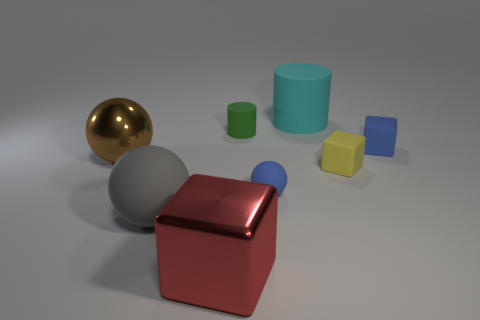Do the blue thing behind the big brown object and the blue matte sphere that is behind the big gray ball have the same size?
Provide a succinct answer. Yes. What number of gray objects are either large matte things or matte balls?
Your answer should be very brief. 1. There is a block that is the same color as the small rubber sphere; what is its size?
Ensure brevity in your answer.  Small. Is the number of tiny cyan metal objects greater than the number of small yellow matte objects?
Your answer should be compact. No. Is the large matte sphere the same color as the tiny matte cylinder?
Your response must be concise. No. What number of objects are either big gray balls or things that are behind the small yellow object?
Make the answer very short. 5. How many other objects are there of the same shape as the green rubber object?
Your answer should be compact. 1. Is the number of big metallic objects that are on the right side of the blue ball less than the number of green rubber cylinders in front of the big brown metal object?
Provide a short and direct response. No. There is a tiny green thing that is the same material as the cyan thing; what is its shape?
Your answer should be compact. Cylinder. Are there any other things that are the same color as the tiny matte sphere?
Provide a short and direct response. Yes. 